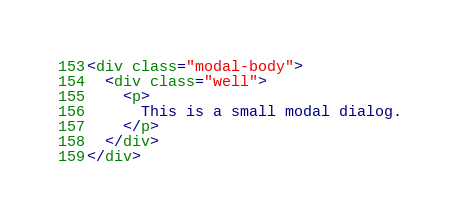Convert code to text. <code><loc_0><loc_0><loc_500><loc_500><_HTML_><div class="modal-body">
  <div class="well">
    <p>
      This is a small modal dialog.
    </p>
  </div>
</div></code> 